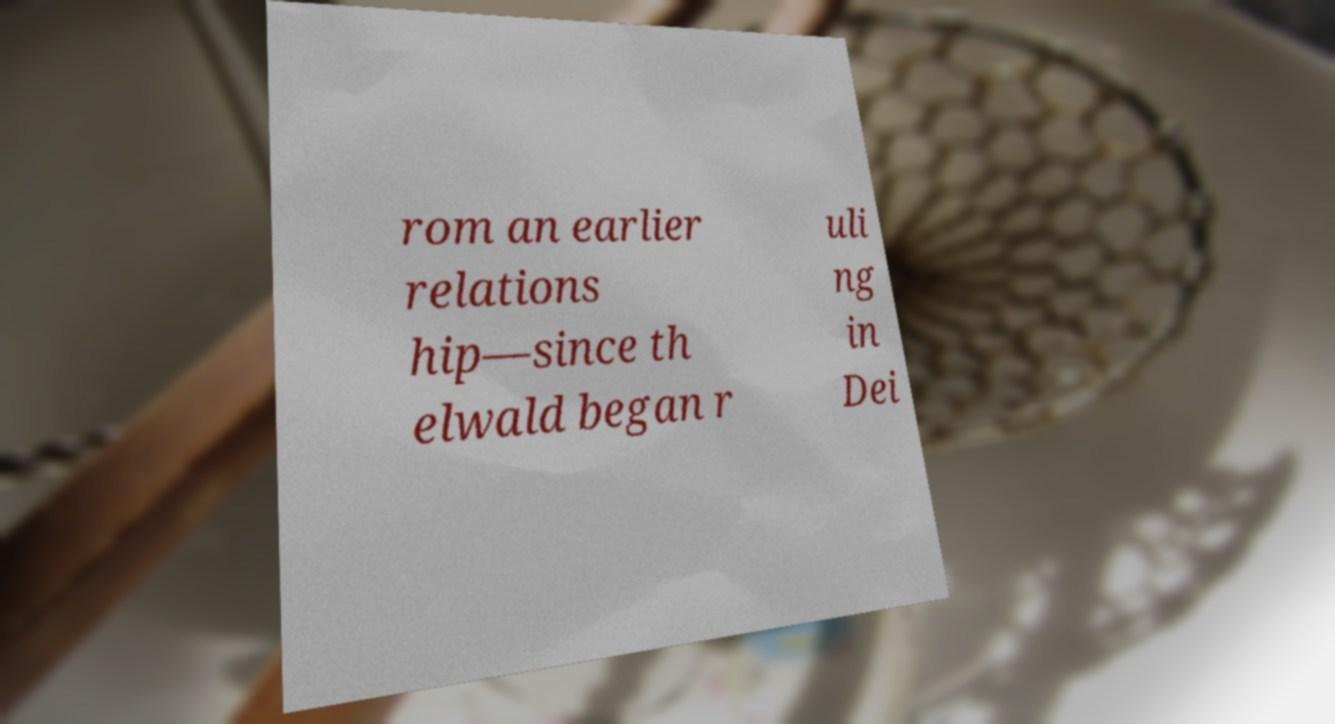Could you assist in decoding the text presented in this image and type it out clearly? rom an earlier relations hip—since th elwald began r uli ng in Dei 